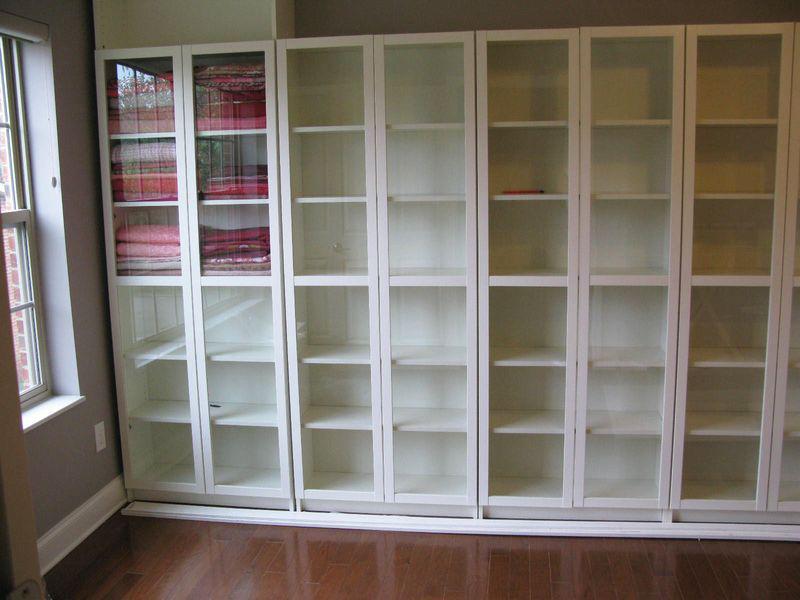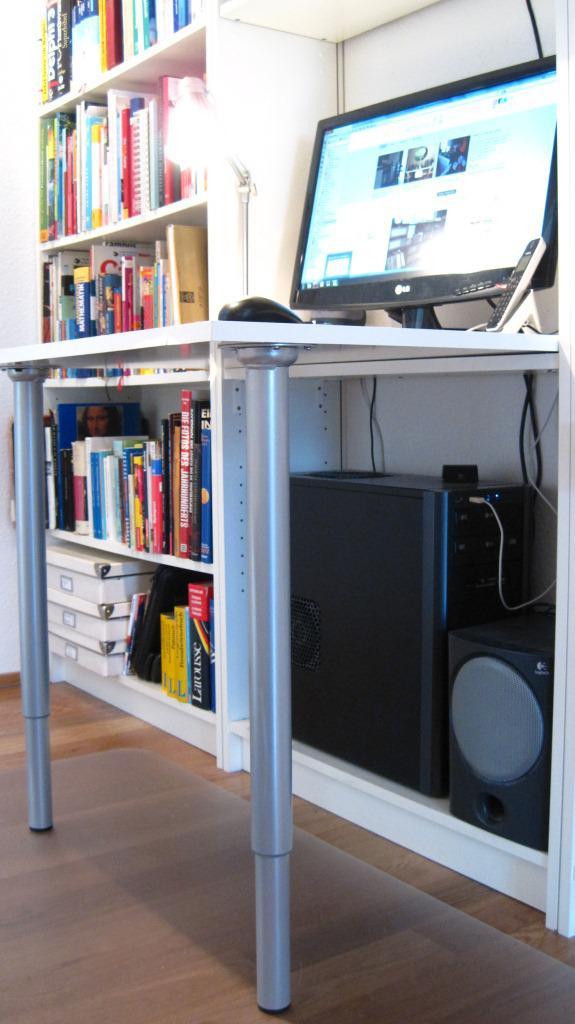The first image is the image on the left, the second image is the image on the right. Assess this claim about the two images: "Three chairs with wheels are in front of a desk in one of the pictures.". Correct or not? Answer yes or no. No. The first image is the image on the left, the second image is the image on the right. Evaluate the accuracy of this statement regarding the images: "One of the images features a desk with three chairs.". Is it true? Answer yes or no. No. 